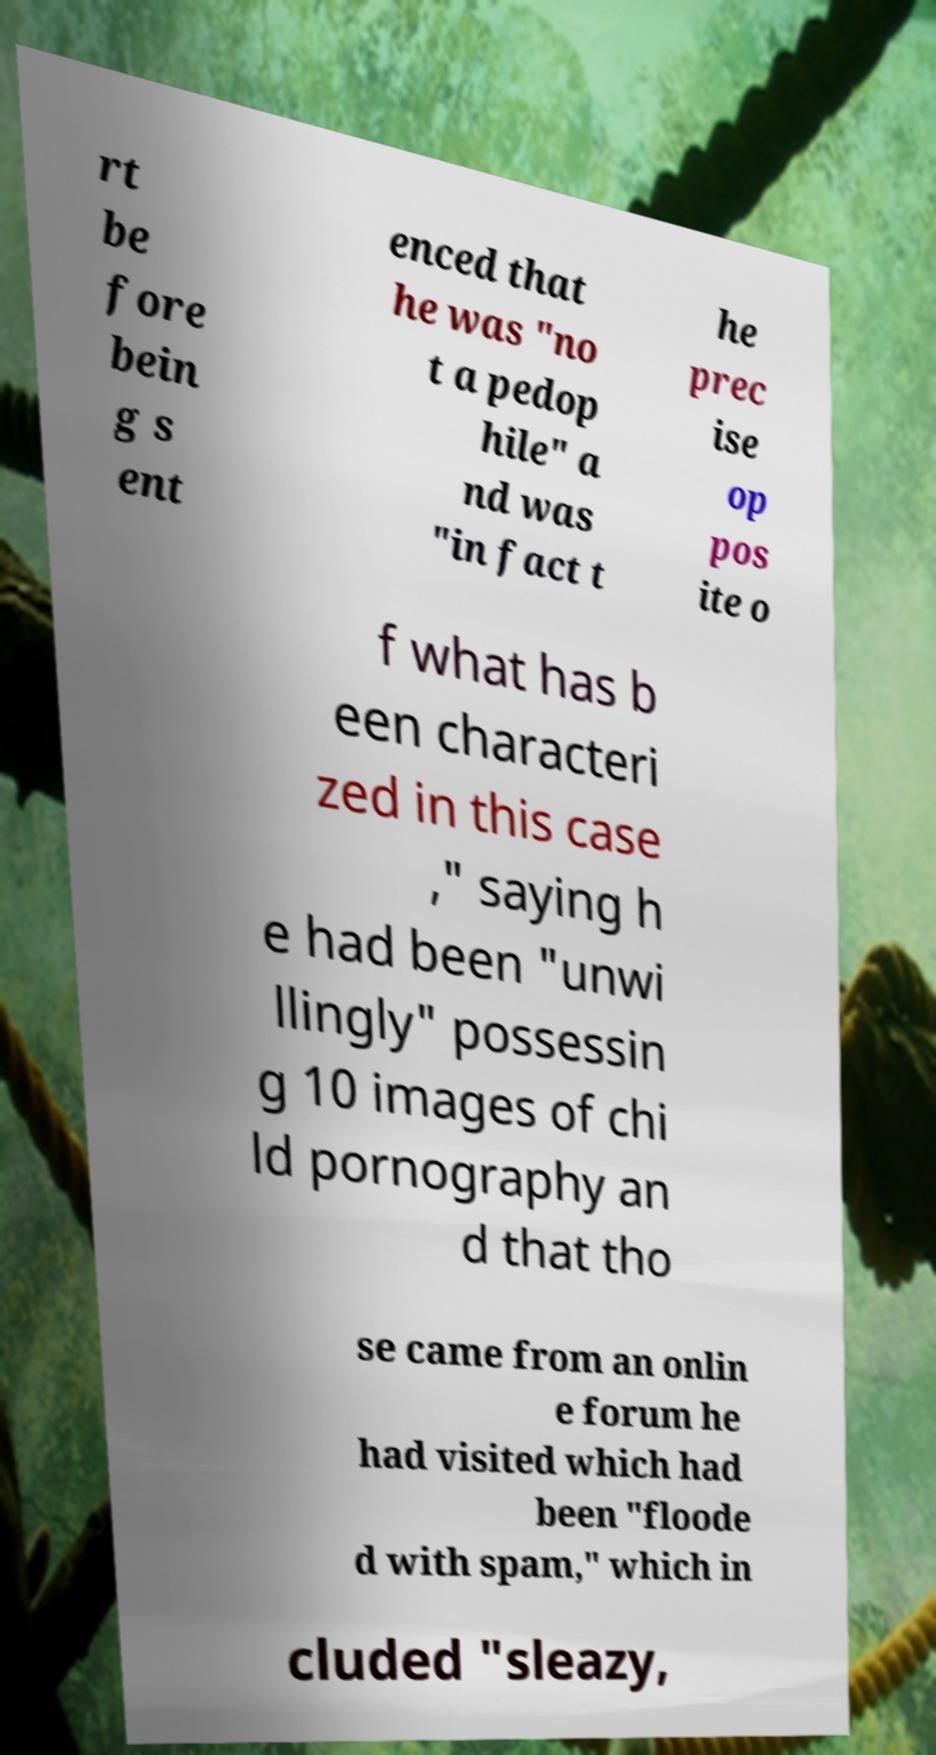There's text embedded in this image that I need extracted. Can you transcribe it verbatim? rt be fore bein g s ent enced that he was "no t a pedop hile" a nd was "in fact t he prec ise op pos ite o f what has b een characteri zed in this case ," saying h e had been "unwi llingly" possessin g 10 images of chi ld pornography an d that tho se came from an onlin e forum he had visited which had been "floode d with spam," which in cluded "sleazy, 